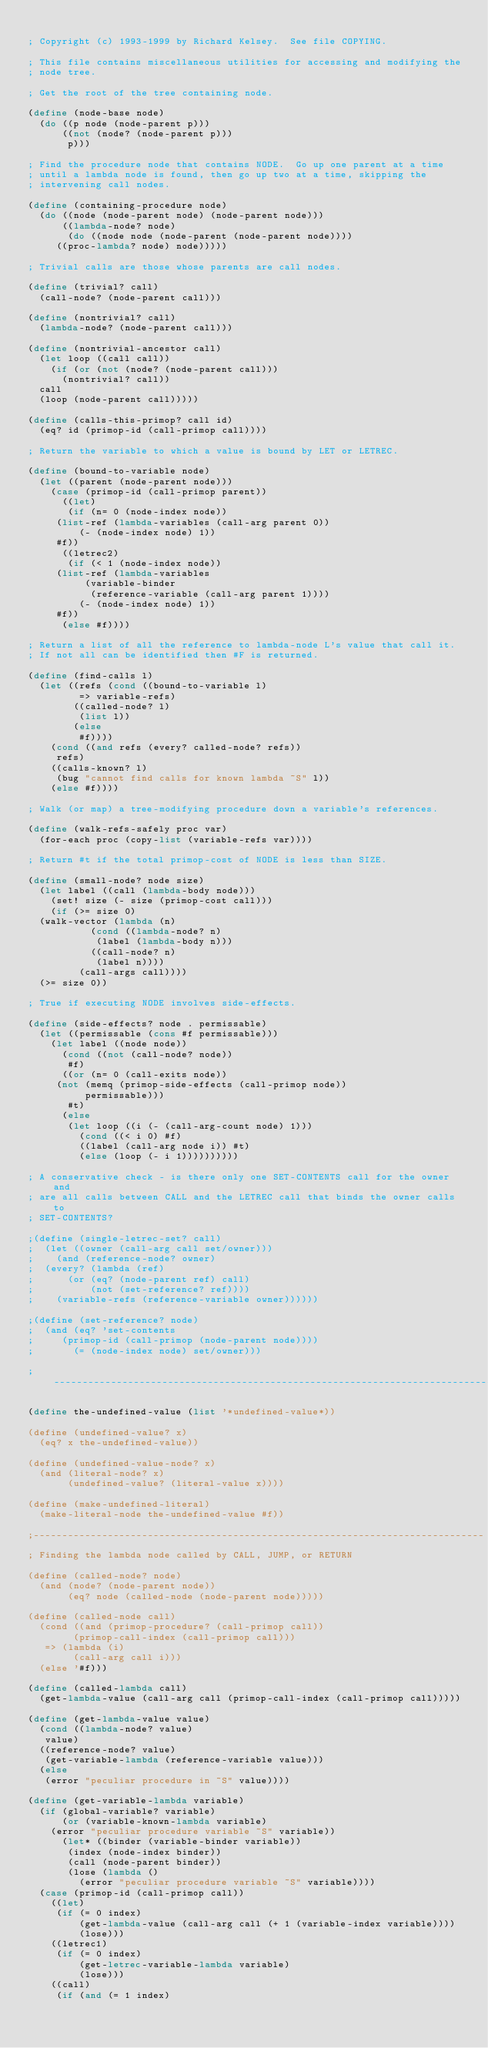Convert code to text. <code><loc_0><loc_0><loc_500><loc_500><_Scheme_> 
; Copyright (c) 1993-1999 by Richard Kelsey.  See file COPYING.

; This file contains miscellaneous utilities for accessing and modifying the
; node tree.

; Get the root of the tree containing node.

(define (node-base node)
  (do ((p node (node-parent p)))
      ((not (node? (node-parent p)))
       p)))

; Find the procedure node that contains NODE.  Go up one parent at a time
; until a lambda node is found, then go up two at a time, skipping the
; intervening call nodes.

(define (containing-procedure node)
  (do ((node (node-parent node) (node-parent node)))
      ((lambda-node? node)
       (do ((node node (node-parent (node-parent node))))
	   ((proc-lambda? node) node)))))

; Trivial calls are those whose parents are call nodes.

(define (trivial? call)
  (call-node? (node-parent call)))

(define (nontrivial? call)
  (lambda-node? (node-parent call)))

(define (nontrivial-ancestor call)
  (let loop ((call call))
    (if (or (not (node? (node-parent call)))
	    (nontrivial? call))
	call
	(loop (node-parent call)))))

(define (calls-this-primop? call id)
  (eq? id (primop-id (call-primop call))))

; Return the variable to which a value is bound by LET or LETREC.

(define (bound-to-variable node)
  (let ((parent (node-parent node)))
    (case (primop-id (call-primop parent))
      ((let)
       (if (n= 0 (node-index node))
	   (list-ref (lambda-variables (call-arg parent 0))
		     (- (node-index node) 1))
	   #f))
      ((letrec2)
       (if (< 1 (node-index node))
	   (list-ref (lambda-variables
		      (variable-binder
		       (reference-variable (call-arg parent 1))))
		     (- (node-index node) 1))
	   #f))
      (else #f))))

; Return a list of all the reference to lambda-node L's value that call it.
; If not all can be identified then #F is returned.

(define (find-calls l)
  (let ((refs (cond ((bound-to-variable l)
		     => variable-refs)
		    ((called-node? l)
		     (list l))
		    (else
		     #f))))
    (cond ((and refs (every? called-node? refs))
	   refs)
	  ((calls-known? l)
	   (bug "cannot find calls for known lambda ~S" l))
	  (else #f))))

; Walk (or map) a tree-modifying procedure down a variable's references.

(define (walk-refs-safely proc var)
  (for-each proc (copy-list (variable-refs var))))

; Return #t if the total primop-cost of NODE is less than SIZE.

(define (small-node? node size)
  (let label ((call (lambda-body node)))
    (set! size (- size (primop-cost call)))
    (if (>= size 0)
	(walk-vector (lambda (n)
		       (cond ((lambda-node? n)
			      (label (lambda-body n)))
			     ((call-node? n)
			      (label n))))
		     (call-args call))))
  (>= size 0))

; True if executing NODE involves side-effects.

(define (side-effects? node . permissable)
  (let ((permissable (cons #f permissable)))
    (let label ((node node))
      (cond ((not (call-node? node))
	     #f)
	    ((or (n= 0 (call-exits node))
		 (not (memq (primop-side-effects (call-primop node))
			    permissable)))
	     #t)
	    (else
	     (let loop ((i (- (call-arg-count node) 1)))
	       (cond ((< i 0) #f)
		     ((label (call-arg node i)) #t)
		     (else (loop (- i 1))))))))))

; A conservative check - is there only one SET-CONTENTS call for the owner and
; are all calls between CALL and the LETREC call that binds the owner calls to
; SET-CONTENTS?

;(define (single-letrec-set? call)
;  (let ((owner (call-arg call set/owner)))
;    (and (reference-node? owner)
;	 (every? (lambda (ref)
;		   (or (eq? (node-parent ref) call)
;		       (not (set-reference? ref))))
;		 (variable-refs (reference-variable owner))))))
    
;(define (set-reference? node)
;  (and (eq? 'set-contents
;	    (primop-id (call-primop (node-parent node))))
;       (= (node-index node) set/owner)))

;-------------------------------------------------------------------------------

(define the-undefined-value (list '*undefined-value*))

(define (undefined-value? x)
  (eq? x the-undefined-value))

(define (undefined-value-node? x)
  (and (literal-node? x)
       (undefined-value? (literal-value x))))

(define (make-undefined-literal)
  (make-literal-node the-undefined-value #f))

;-------------------------------------------------------------------------------
; Finding the lambda node called by CALL, JUMP, or RETURN

(define (called-node? node)
  (and (node? (node-parent node))
       (eq? node (called-node (node-parent node)))))
						   
(define (called-node call)
  (cond ((and (primop-procedure? (call-primop call))
	      (primop-call-index (call-primop call)))
	 => (lambda (i)
	      (call-arg call i)))
	(else '#f)))

(define (called-lambda call)
  (get-lambda-value (call-arg call (primop-call-index (call-primop call)))))

(define (get-lambda-value value)
  (cond ((lambda-node? value)
	 value)
	((reference-node? value)
	 (get-variable-lambda (reference-variable value)))
	(else
	 (error "peculiar procedure in ~S" value))))

(define (get-variable-lambda variable)
  (if (global-variable? variable)
      (or (variable-known-lambda variable)
	  (error "peculiar procedure variable ~S" variable))
      (let* ((binder (variable-binder variable))
	     (index (node-index binder))
	     (call (node-parent binder))
	     (lose (lambda ()
		     (error "peculiar procedure variable ~S" variable))))
	(case (primop-id (call-primop call))
	  ((let)
	   (if (= 0 index)
	       (get-lambda-value (call-arg call (+ 1 (variable-index variable))))
	       (lose)))
	  ((letrec1)
	   (if (= 0 index)
	       (get-letrec-variable-lambda variable)
	       (lose)))
	  ((call)
	   (if (and (= 1 index)</code> 